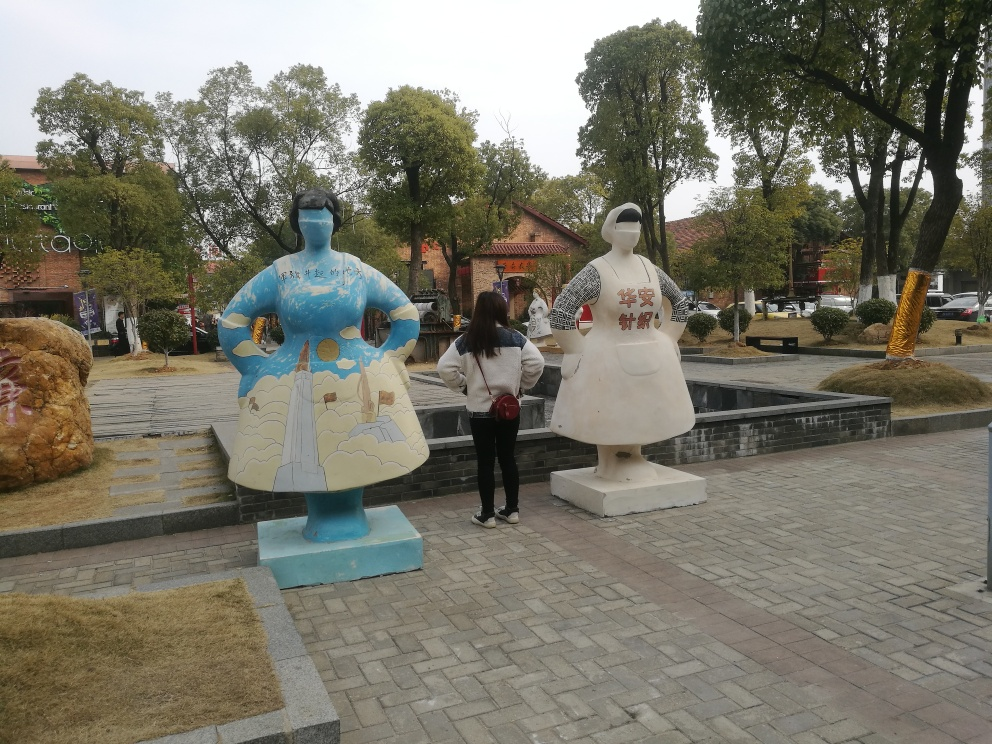Are the decorations and pedestrians on the road clear? While some elements are discernible, the decorations and pedestrians on the road are not entirely clear due to the angle and distance at which the photo was taken. The focus seems to be on the two large painted statues in the foreground, which may obscure detailed views of other potential decorations and any pedestrians that might be present further down the road. 